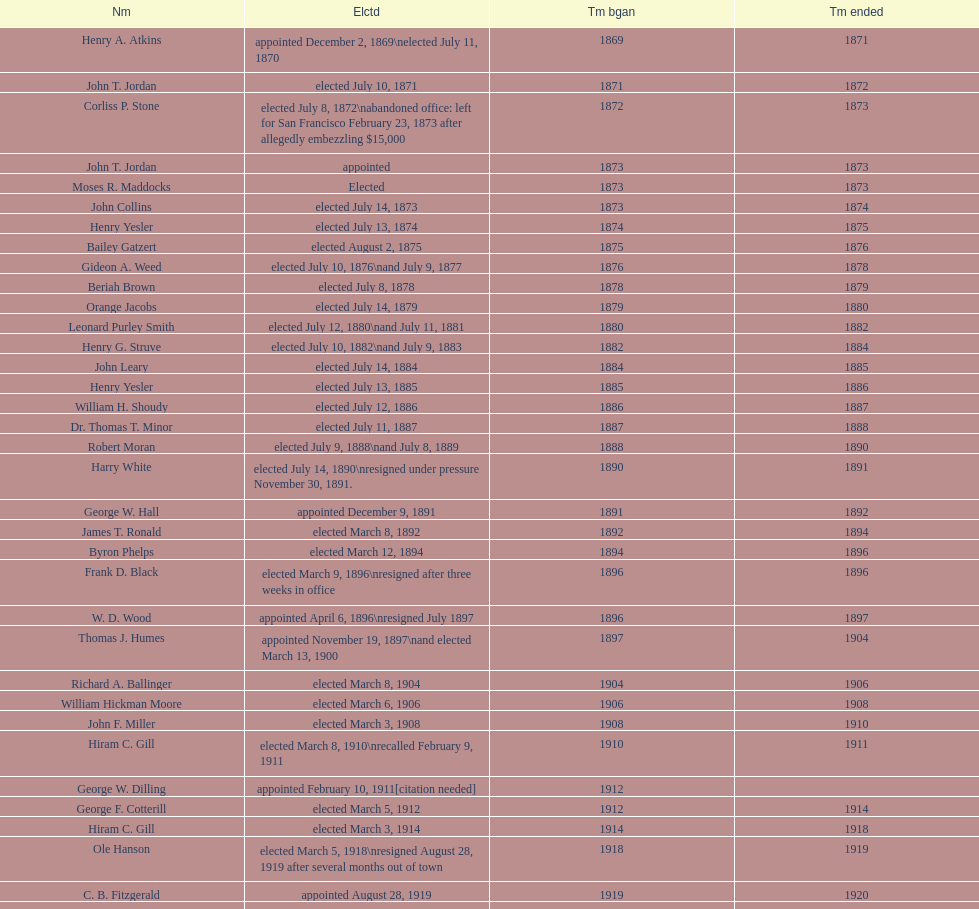Which individual was the mayor preceding jordan? Henry A. Atkins. Give me the full table as a dictionary. {'header': ['Nm', 'Elctd', 'Tm bgan', 'Tm ended'], 'rows': [['Henry A. Atkins', 'appointed December 2, 1869\\nelected July 11, 1870', '1869', '1871'], ['John T. Jordan', 'elected July 10, 1871', '1871', '1872'], ['Corliss P. Stone', 'elected July 8, 1872\\nabandoned office: left for San Francisco February 23, 1873 after allegedly embezzling $15,000', '1872', '1873'], ['John T. Jordan', 'appointed', '1873', '1873'], ['Moses R. Maddocks', 'Elected', '1873', '1873'], ['John Collins', 'elected July 14, 1873', '1873', '1874'], ['Henry Yesler', 'elected July 13, 1874', '1874', '1875'], ['Bailey Gatzert', 'elected August 2, 1875', '1875', '1876'], ['Gideon A. Weed', 'elected July 10, 1876\\nand July 9, 1877', '1876', '1878'], ['Beriah Brown', 'elected July 8, 1878', '1878', '1879'], ['Orange Jacobs', 'elected July 14, 1879', '1879', '1880'], ['Leonard Purley Smith', 'elected July 12, 1880\\nand July 11, 1881', '1880', '1882'], ['Henry G. Struve', 'elected July 10, 1882\\nand July 9, 1883', '1882', '1884'], ['John Leary', 'elected July 14, 1884', '1884', '1885'], ['Henry Yesler', 'elected July 13, 1885', '1885', '1886'], ['William H. Shoudy', 'elected July 12, 1886', '1886', '1887'], ['Dr. Thomas T. Minor', 'elected July 11, 1887', '1887', '1888'], ['Robert Moran', 'elected July 9, 1888\\nand July 8, 1889', '1888', '1890'], ['Harry White', 'elected July 14, 1890\\nresigned under pressure November 30, 1891.', '1890', '1891'], ['George W. Hall', 'appointed December 9, 1891', '1891', '1892'], ['James T. Ronald', 'elected March 8, 1892', '1892', '1894'], ['Byron Phelps', 'elected March 12, 1894', '1894', '1896'], ['Frank D. Black', 'elected March 9, 1896\\nresigned after three weeks in office', '1896', '1896'], ['W. D. Wood', 'appointed April 6, 1896\\nresigned July 1897', '1896', '1897'], ['Thomas J. Humes', 'appointed November 19, 1897\\nand elected March 13, 1900', '1897', '1904'], ['Richard A. Ballinger', 'elected March 8, 1904', '1904', '1906'], ['William Hickman Moore', 'elected March 6, 1906', '1906', '1908'], ['John F. Miller', 'elected March 3, 1908', '1908', '1910'], ['Hiram C. Gill', 'elected March 8, 1910\\nrecalled February 9, 1911', '1910', '1911'], ['George W. Dilling', 'appointed February 10, 1911[citation needed]', '1912', ''], ['George F. Cotterill', 'elected March 5, 1912', '1912', '1914'], ['Hiram C. Gill', 'elected March 3, 1914', '1914', '1918'], ['Ole Hanson', 'elected March 5, 1918\\nresigned August 28, 1919 after several months out of town', '1918', '1919'], ['C. B. Fitzgerald', 'appointed August 28, 1919', '1919', '1920'], ['Hugh M. Caldwell', 'elected March 2, 1920', '1920', '1922'], ['Edwin J. Brown', 'elected May 2, 1922\\nand March 4, 1924', '1922', '1926'], ['Bertha Knight Landes', 'elected March 9, 1926', '1926', '1928'], ['Frank E. Edwards', 'elected March 6, 1928\\nand March 4, 1930\\nrecalled July 13, 1931', '1928', '1931'], ['Robert H. Harlin', 'appointed July 14, 1931', '1931', '1932'], ['John F. Dore', 'elected March 8, 1932', '1932', '1934'], ['Charles L. Smith', 'elected March 6, 1934', '1934', '1936'], ['John F. Dore', 'elected March 3, 1936\\nbecame gravely ill and was relieved of office April 13, 1938, already a lame duck after the 1938 election. He died five days later.', '1936', '1938'], ['Arthur B. Langlie', "elected March 8, 1938\\nappointed to take office early, April 27, 1938, after Dore's death.\\nelected March 5, 1940\\nresigned January 11, 1941, to become Governor of Washington", '1938', '1941'], ['John E. Carroll', 'appointed January 27, 1941', '1941', '1941'], ['Earl Millikin', 'elected March 4, 1941', '1941', '1942'], ['William F. Devin', 'elected March 3, 1942, March 7, 1944, March 5, 1946, and March 2, 1948', '1942', '1952'], ['Allan Pomeroy', 'elected March 4, 1952', '1952', '1956'], ['Gordon S. Clinton', 'elected March 6, 1956\\nand March 8, 1960', '1956', '1964'], ["James d'Orma Braman", 'elected March 10, 1964\\nresigned March 23, 1969, to accept an appointment as an Assistant Secretary in the Department of Transportation in the Nixon administration.', '1964', '1969'], ['Floyd C. Miller', 'appointed March 23, 1969', '1969', '1969'], ['Wesley C. Uhlman', 'elected November 4, 1969\\nand November 6, 1973\\nsurvived recall attempt on July 1, 1975', 'December 1, 1969', 'January 1, 1978'], ['Charles Royer', 'elected November 8, 1977, November 3, 1981, and November 5, 1985', 'January 1, 1978', 'January 1, 1990'], ['Norman B. Rice', 'elected November 7, 1989', 'January 1, 1990', 'January 1, 1998'], ['Paul Schell', 'elected November 4, 1997', 'January 1, 1998', 'January 1, 2002'], ['Gregory J. Nickels', 'elected November 6, 2001\\nand November 8, 2005', 'January 1, 2002', 'January 1, 2010'], ['Michael McGinn', 'elected November 3, 2009', 'January 1, 2010', 'January 1, 2014'], ['Ed Murray', 'elected November 5, 2013', 'January 1, 2014', 'present']]} 